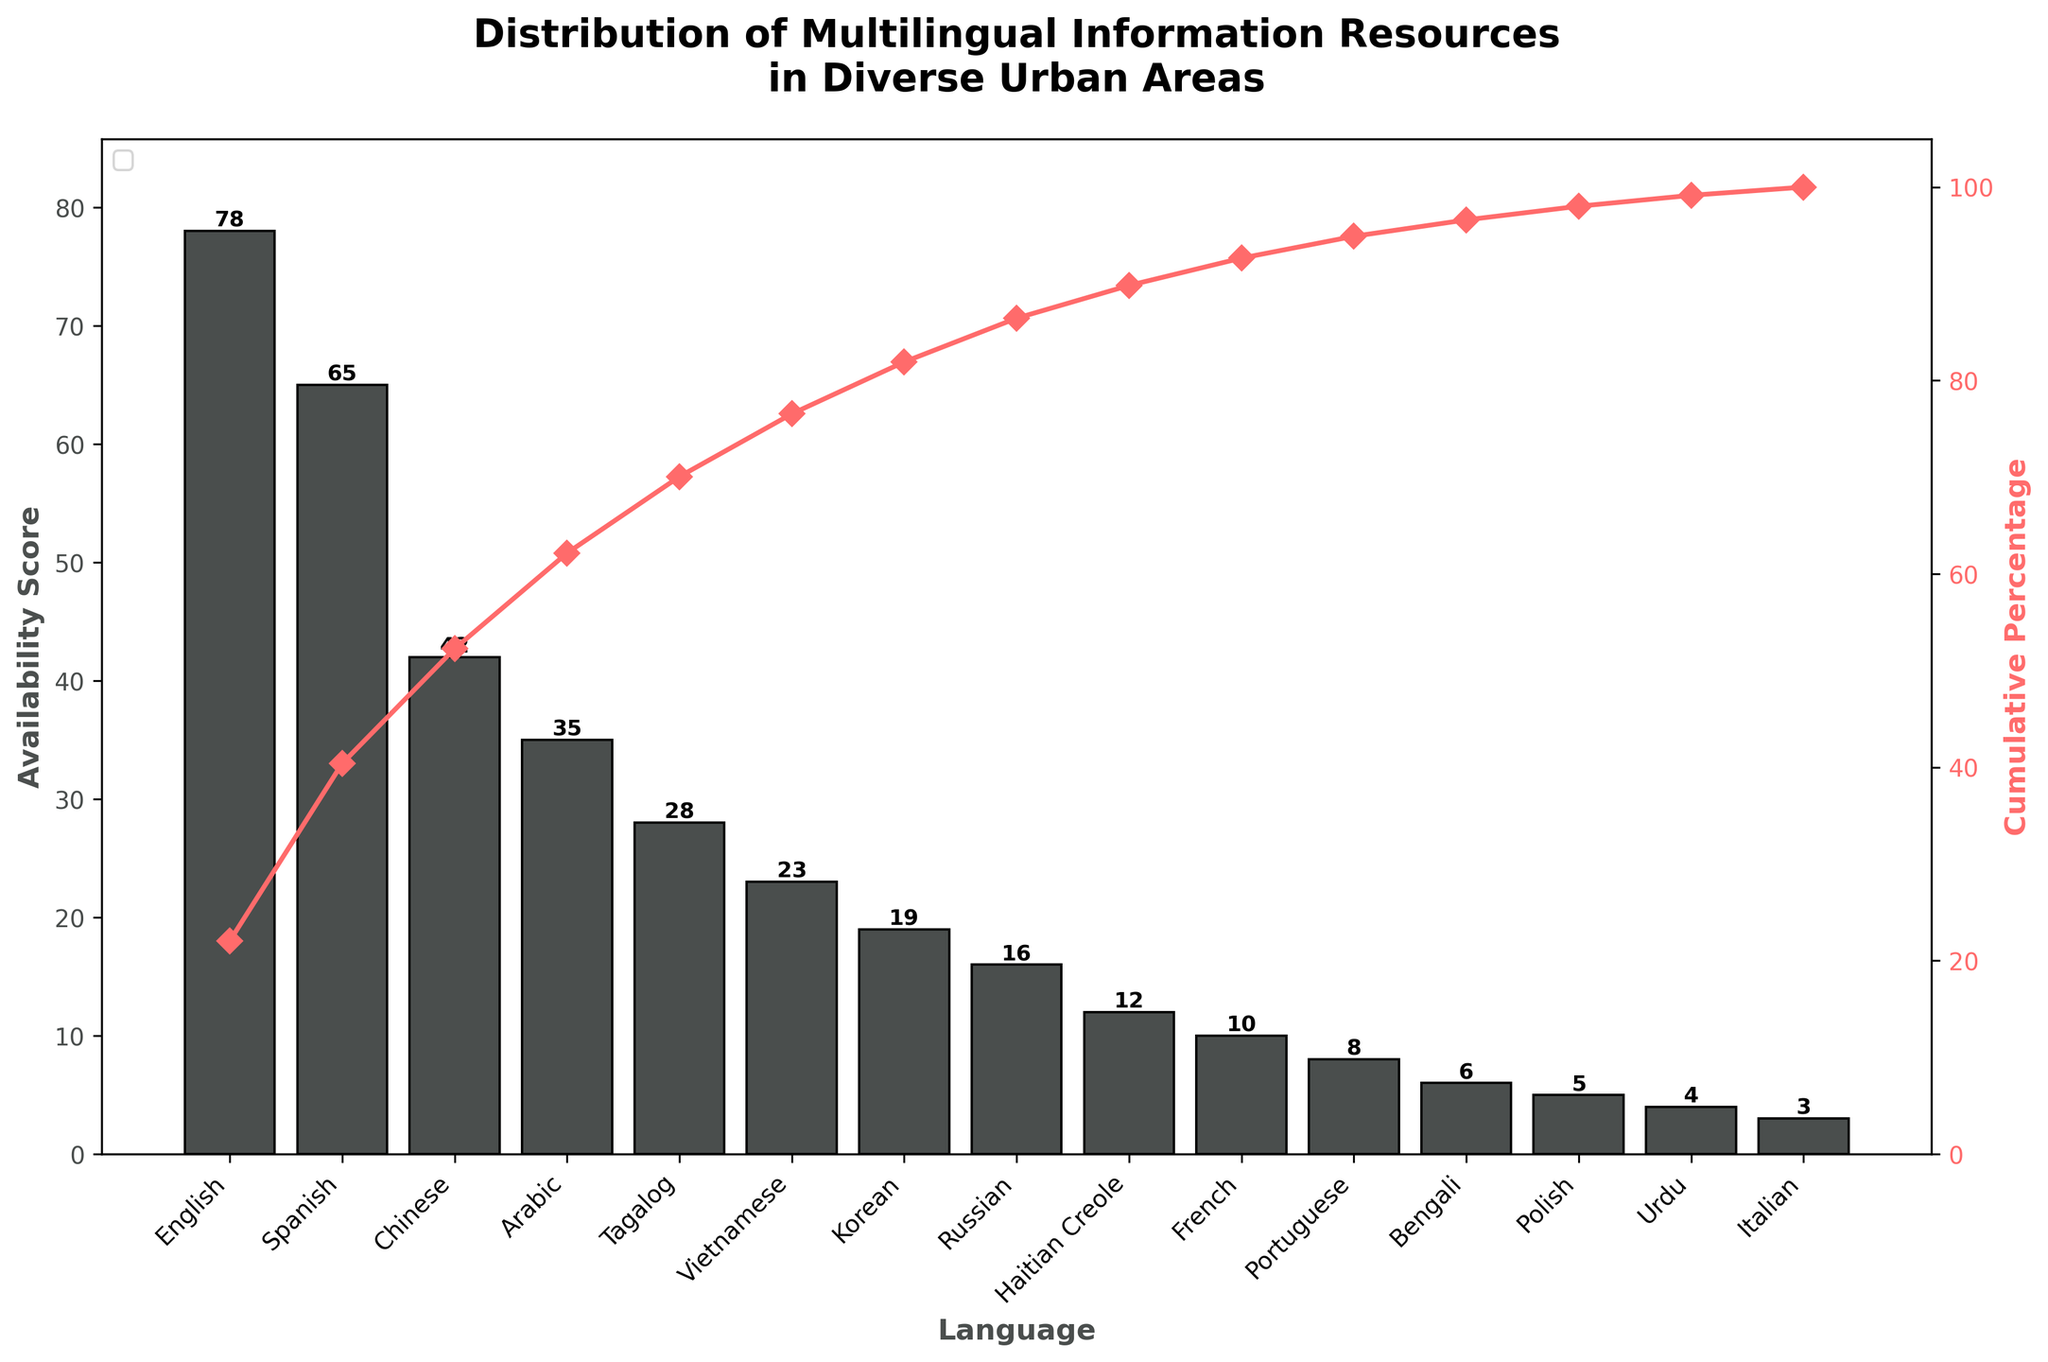What language has the highest availability score? The language with the highest availability score is shown as the tallest bar in the figure. This bar is labeled with the language "English."
Answer: English What is the cumulative percentage for English and Spanish combined? The cumulative percentage can be found on the secondary (right) y-axis. Adding the availability scores for English (78) and Spanish (65) gives 143. The total availability score for all languages is 350. To find the cumulative percentage: (143/350)*100 ≈ 40.86%.
Answer: 40.86% How many languages have an availability score over 20? By analyzing the figure, we count the bars that have heights greater than the 20 mark on the primary (left) y-axis. These languages are English, Spanish, Chinese, Arabic, Tagalog, and Vietnamese, totaling to 6 languages.
Answer: 6 Which language marks the 80% cumulative percentage on the graph? To find this, we follow the line plot representing cumulative percentage. The point at which this curve reaches 80% occurs just after the Korean language. Hence, Korean marks the 80% cumulative percentage.
Answer: Korean How does the availability score of French compare to that of Korean? In the figure, the height of the bar for French is 10, while for Korean it is 19. By comparing these two heights, we see that Korean's availability score is almost double that of French.
Answer: Korean has a higher score than French What languages make up the lowest 25% cumulative availability score? To identify this, first calculate 25% of the total score (350), which is 87.5. Summing the availability scores from the lowest upward: Italian (3), Urdu (4), Polish (5), Bengali (6), Portuguese (8), French (10), and Haitian Creole (12) result in a cumulative score of 48. Adding Russian (16) makes it 64. Adding Korean (19) reaches 83. Finally, adding Vietnamese (23) exceeds 87.5. So, the lowest 25% include Italian, Urdu, Polish, Bengali, Portuguese, French, Haitian Creole, and Russian.
Answer: Russian and those below it Which language has the smallest contribution to the total availability score? The smallest bar in the figure represents the language with the lowest availability score. According to the chart, Italian has the smallest bar with a score of 3.
Answer: Italian What is the total availability score of the languages with cumulative percentages above 90%? This requires identifying languages for which the cumulative percentage is above 90%. From the chart, these include Haitian Creole (12), French (10), Portuguese (8), Bengali (6), Polish (5), Urdu (4), and Italian (3). Adding these scores: 12 + 10 + 8 + 6 + 5 + 4 + 3 = 48.
Answer: 48 What's the difference in availability score between Chinese and Arabic? The heights of the bars for Chinese and Arabic are 42 and 35, respectively. To find the difference, subtract the score of Arabic from Chinese: 42 - 35 = 7.
Answer: 7 